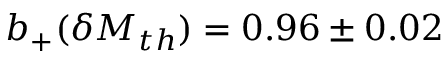<formula> <loc_0><loc_0><loc_500><loc_500>b _ { + } ( \delta M _ { t h } ) = 0 . 9 6 \pm 0 . 0 2</formula> 